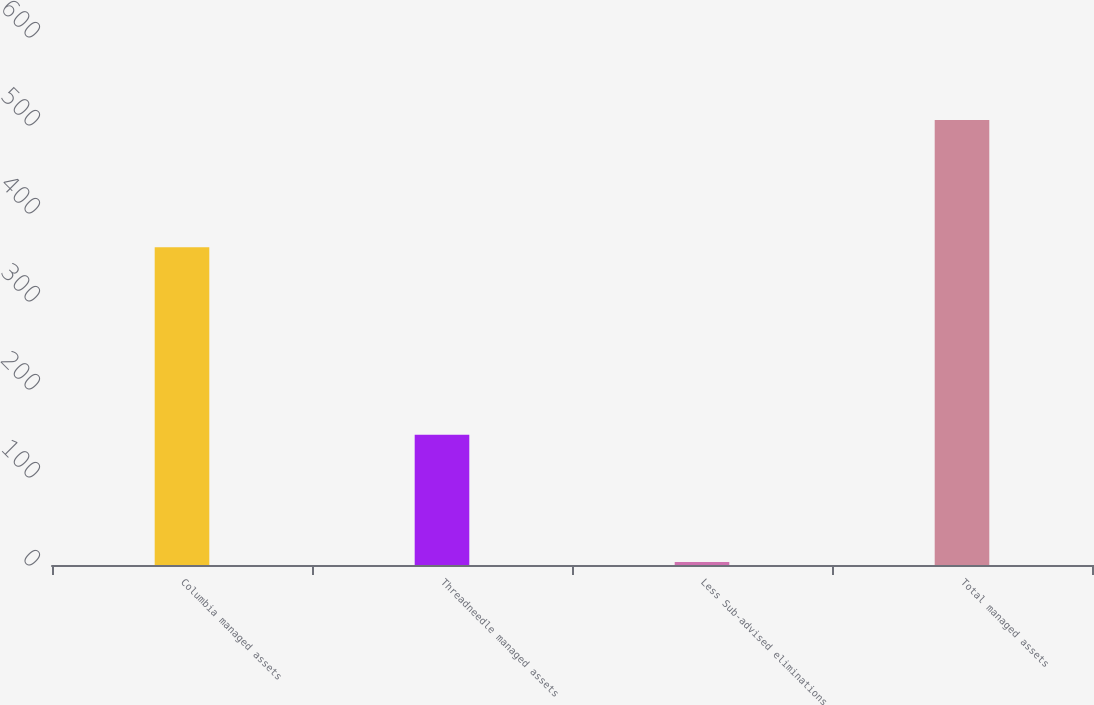Convert chart to OTSL. <chart><loc_0><loc_0><loc_500><loc_500><bar_chart><fcel>Columbia managed assets<fcel>Threadneedle managed assets<fcel>Less Sub-advised eliminations<fcel>Total managed assets<nl><fcel>361.2<fcel>147.9<fcel>3.5<fcel>505.6<nl></chart> 